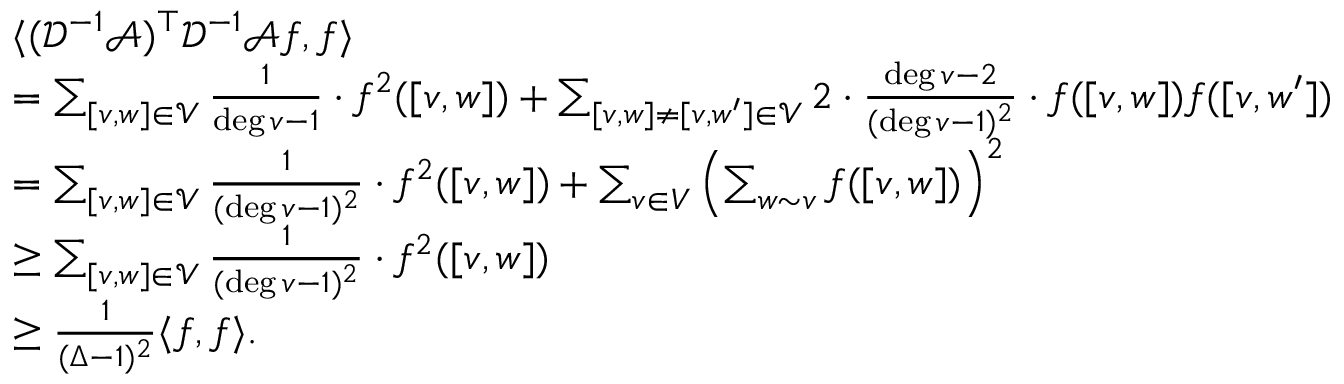<formula> <loc_0><loc_0><loc_500><loc_500>\begin{array} { r l } & { \langle ( \mathcal { D } ^ { - 1 } \mathcal { A } ) ^ { \top } \mathcal { D } ^ { - 1 } \mathcal { A } f , f \rangle } \\ & { = \sum _ { [ v , w ] \in \mathcal { V } } \frac { 1 } { \deg v - 1 } \cdot f ^ { 2 } ( [ v , w ] ) + \sum _ { [ v , w ] \ne [ v , w ^ { \prime } ] \in \mathcal { V } } 2 \cdot \frac { \deg v - 2 } { ( \deg v - 1 ) ^ { 2 } } \cdot f ( [ v , w ] ) f ( [ v , w ^ { \prime } ] ) } \\ & { = \sum _ { [ v , w ] \in \mathcal { V } } \frac { 1 } { ( \deg v - 1 ) ^ { 2 } } \cdot f ^ { 2 } ( [ v , w ] ) + \sum _ { v \in V } \left ( \sum _ { w \sim v } f ( [ v , w ] ) \right ) ^ { 2 } } \\ & { \geq \sum _ { [ v , w ] \in \mathcal { V } } \frac { 1 } { ( \deg v - 1 ) ^ { 2 } } \cdot f ^ { 2 } ( [ v , w ] ) } \\ & { \geq \frac { 1 } { ( \Delta - 1 ) ^ { 2 } } \langle f , f \rangle . } \end{array}</formula> 